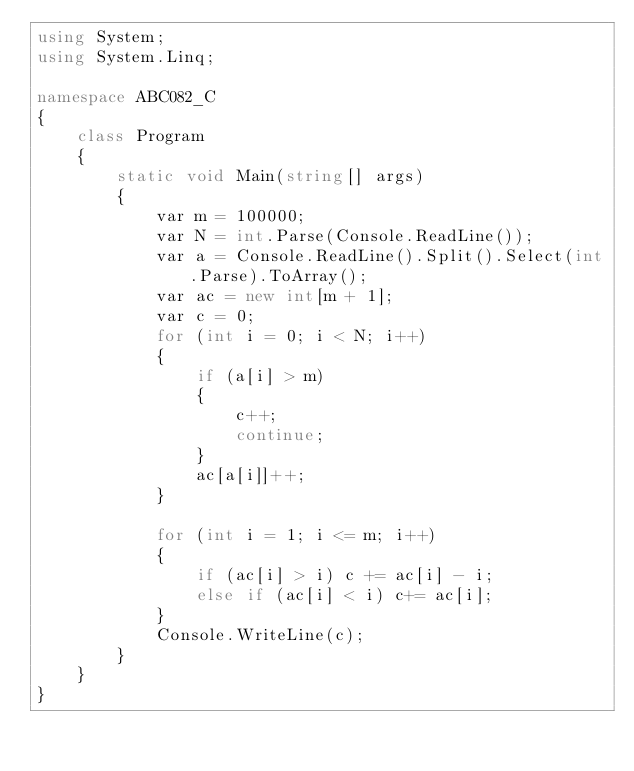<code> <loc_0><loc_0><loc_500><loc_500><_C#_>using System;
using System.Linq;

namespace ABC082_C
{
    class Program
    {
        static void Main(string[] args)
        {
            var m = 100000;
            var N = int.Parse(Console.ReadLine());
            var a = Console.ReadLine().Split().Select(int.Parse).ToArray();
            var ac = new int[m + 1];
            var c = 0;
            for (int i = 0; i < N; i++)
            {
                if (a[i] > m)
                {
                    c++;
                    continue;
                }
                ac[a[i]]++;
            }

            for (int i = 1; i <= m; i++)
            {
                if (ac[i] > i) c += ac[i] - i;
                else if (ac[i] < i) c+= ac[i];
            }
            Console.WriteLine(c);
        }
    }
}
</code> 